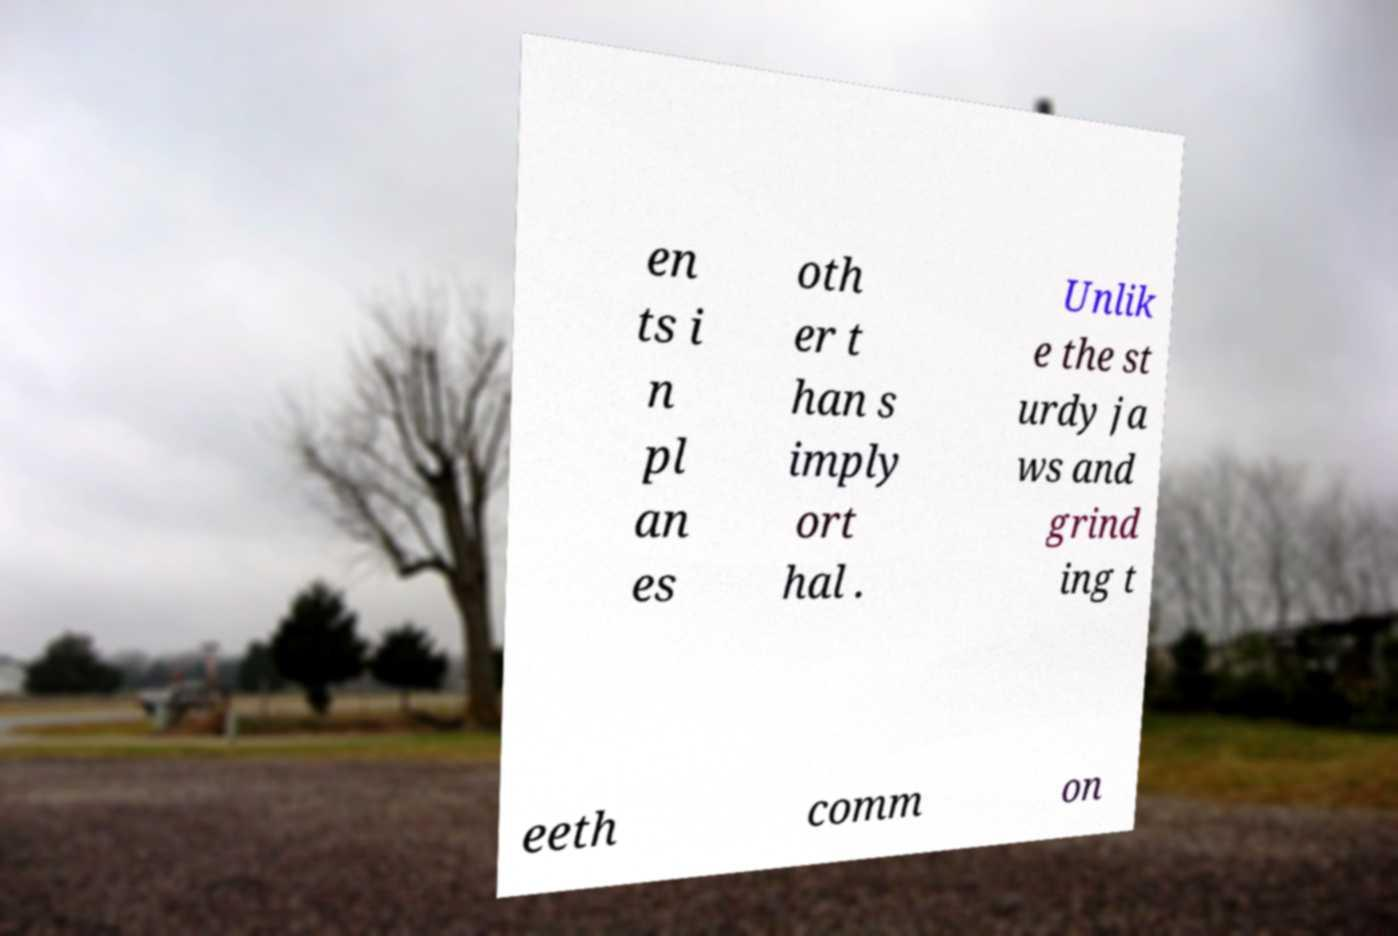There's text embedded in this image that I need extracted. Can you transcribe it verbatim? en ts i n pl an es oth er t han s imply ort hal . Unlik e the st urdy ja ws and grind ing t eeth comm on 